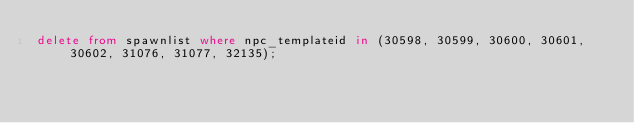Convert code to text. <code><loc_0><loc_0><loc_500><loc_500><_SQL_>delete from spawnlist where npc_templateid in (30598, 30599, 30600, 30601, 30602, 31076, 31077, 32135);
</code> 